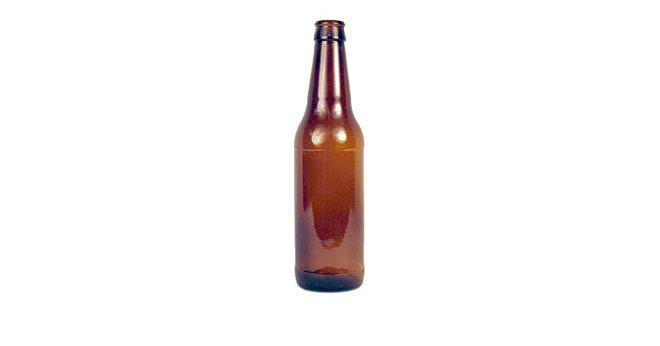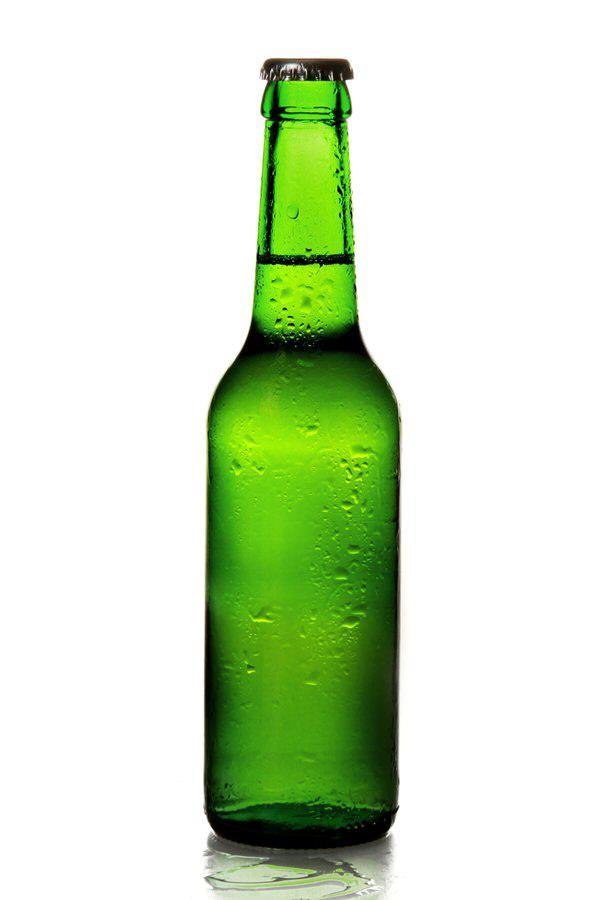The first image is the image on the left, the second image is the image on the right. Given the left and right images, does the statement "More bottles are depicted in the right image than the left." hold true? Answer yes or no. No. 